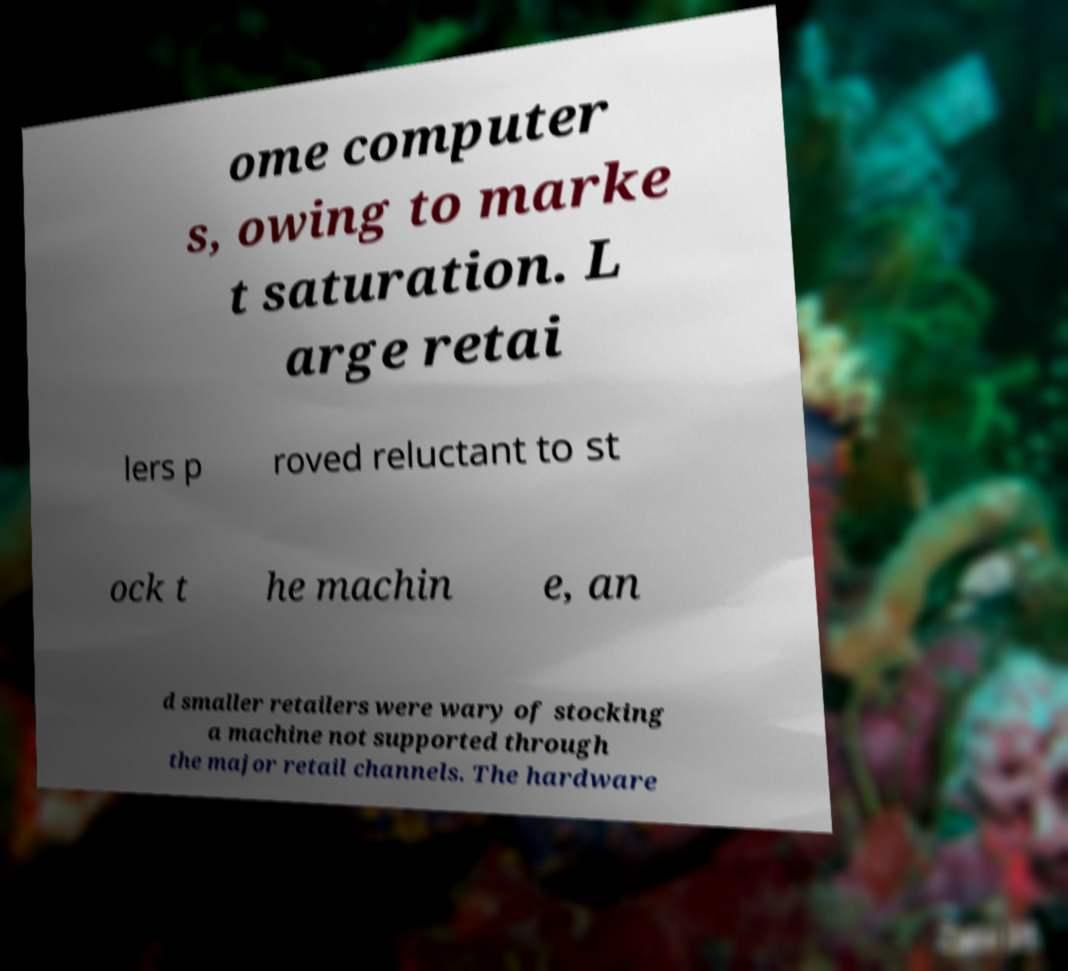There's text embedded in this image that I need extracted. Can you transcribe it verbatim? ome computer s, owing to marke t saturation. L arge retai lers p roved reluctant to st ock t he machin e, an d smaller retailers were wary of stocking a machine not supported through the major retail channels. The hardware 